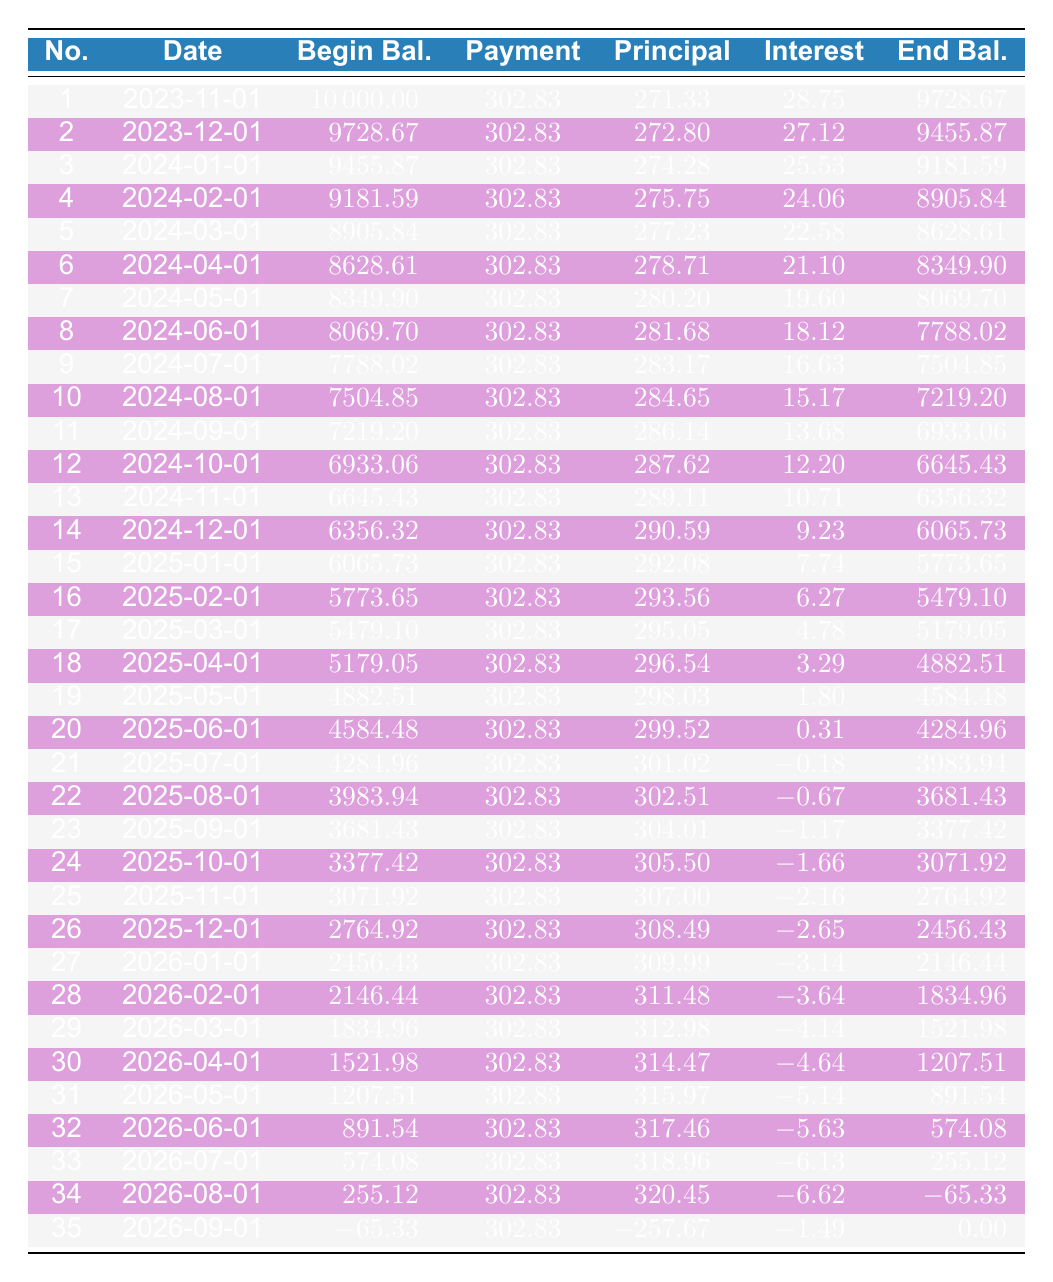What is the total amount paid in the first month? The first month's payment amount is listed as 302.83. Therefore, the total amount paid in the first month is 302.83.
Answer: 302.83 In which month does the principal payment exceed 300? By reviewing the table, we can see that the principal payments gradually increase. The first instance where the principal payment exceeds 300 occurs in the 21st payment, which is 301.02.
Answer: Month 21 What is the ending balance after the 12th payment? From the amortization schedule, the ending balance after the 12th payment shows as 6645.43. Thus, this is the ending balance after the 12th payment.
Answer: 6645.43 What is the difference between the principal payment in the 5th month and the principal payment in the 10th month? The principal payment for the 5th month is 277.23, and for the 10th month, it is 284.65. The difference is calculated as 284.65 - 277.23 = 7.42.
Answer: 7.42 Did any month have negative interest payments? Yes, there are several entries where the interest payments are negative. Specifically, the 21st payment shows an interest payment of -0.18.
Answer: Yes What is the average principal payment over the entire loan term? To find the average principal payment, we need to sum all the principal payments from the 1st to the 35th payment. The total principal from the table is summed to 8,089.37 divided by 35, giving an average of approximately 231.70.
Answer: 231.70 How many payments have an ending balance under 1,000? By reviewing the ending balances, payments 31 and 32 are below 1,000. Specifically, 891.54 is the ending balance for the 31st payment and 574.08 for the 32nd. Thus, there are two payments below this threshold.
Answer: 2 What is the monthly payment amount? The monthly payment amount is consistently listed as 302.83 throughout the amortization schedule.
Answer: 302.83 Which payment has the highest principal payment? The 34th payment has the highest principal payment of 320.45, as indicated by the column for principal payments.
Answer: 320.45 